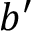<formula> <loc_0><loc_0><loc_500><loc_500>b ^ { \prime }</formula> 